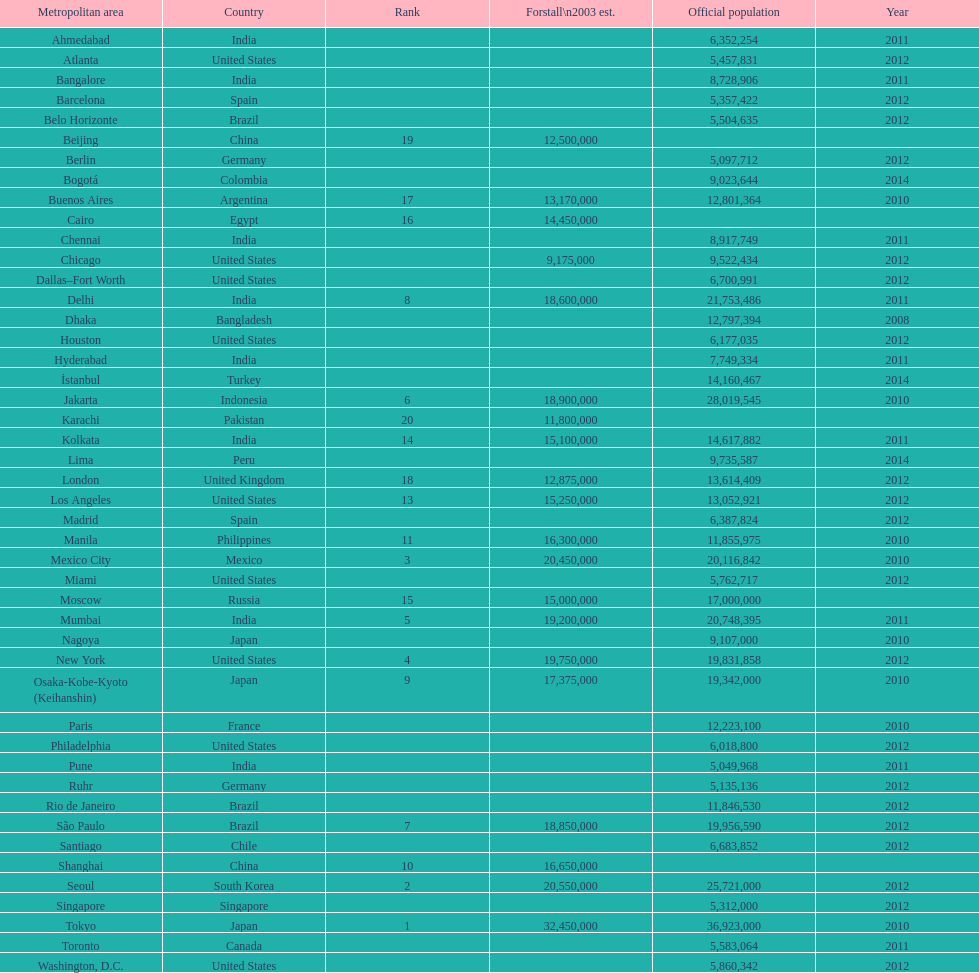Which territory is cited above chicago? Chennai. 